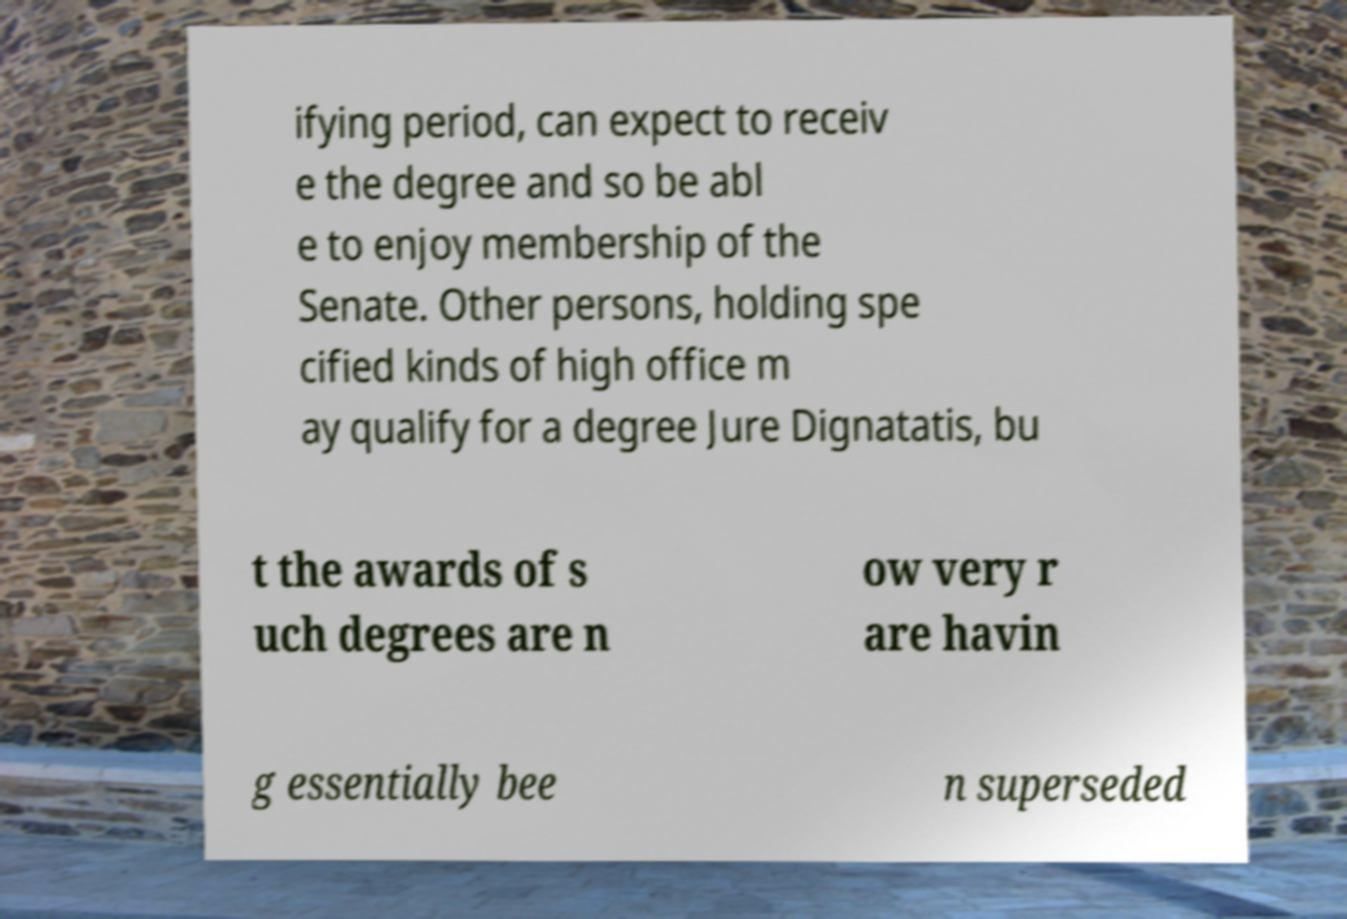Could you extract and type out the text from this image? ifying period, can expect to receiv e the degree and so be abl e to enjoy membership of the Senate. Other persons, holding spe cified kinds of high office m ay qualify for a degree Jure Dignatatis, bu t the awards of s uch degrees are n ow very r are havin g essentially bee n superseded 